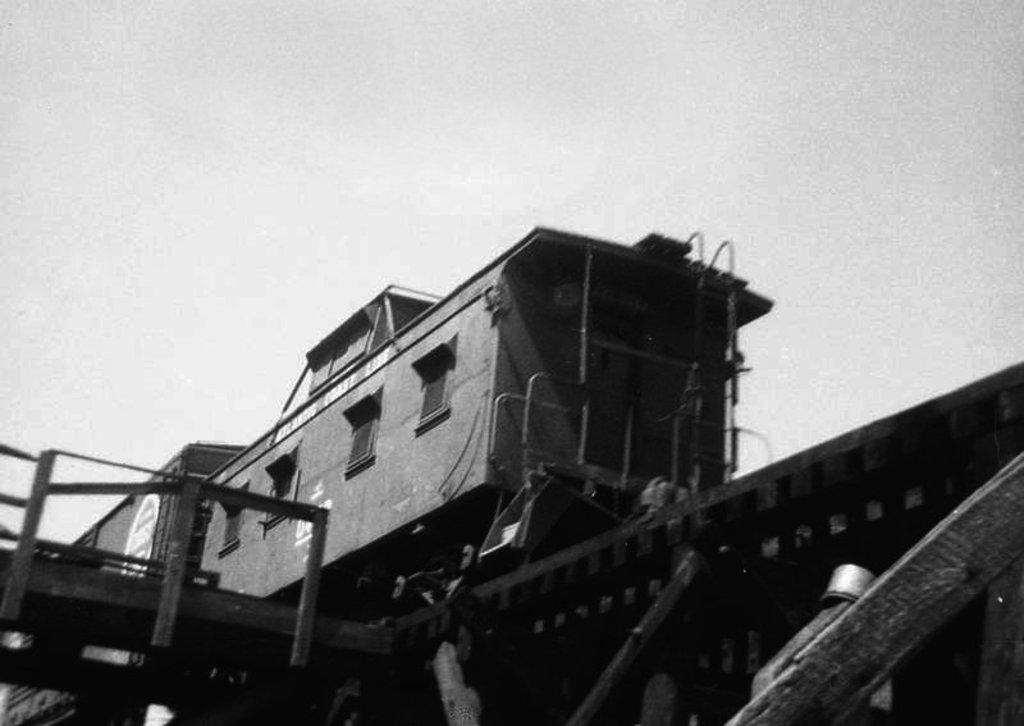What is the main subject of the image? The main subject of the image is a train. What is the train situated on in the image? The train is situated on a railway track in the image. What can be seen in the background of the image? The sky is visible in the image. Where is the cemetery located in the image? There is no cemetery present in the image; it features a train on a railway track with the sky visible in the background. What type of cake is being served on the train in the image? There is no cake present in the image; it only shows a train on a railway track with the sky visible in the background. 